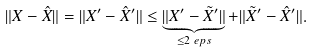<formula> <loc_0><loc_0><loc_500><loc_500>\| X - \hat { X } \| & = \| X ^ { \prime } - \hat { X } ^ { \prime } \| \leq \underbrace { \| X ^ { \prime } - \tilde { X } ^ { \prime } \| } _ { \leq 2 \ e p s } + \| \tilde { X } ^ { \prime } - \hat { X } ^ { \prime } \| .</formula> 